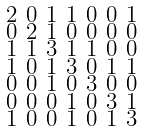Convert formula to latex. <formula><loc_0><loc_0><loc_500><loc_500>\begin{smallmatrix} 2 & 0 & 1 & 1 & 0 & 0 & 1 \\ 0 & 2 & 1 & 0 & 0 & 0 & 0 \\ 1 & 1 & 3 & 1 & 1 & 0 & 0 \\ 1 & 0 & 1 & 3 & 0 & 1 & 1 \\ 0 & 0 & 1 & 0 & 3 & 0 & 0 \\ 0 & 0 & 0 & 1 & 0 & 3 & 1 \\ 1 & 0 & 0 & 1 & 0 & 1 & 3 \end{smallmatrix}</formula> 